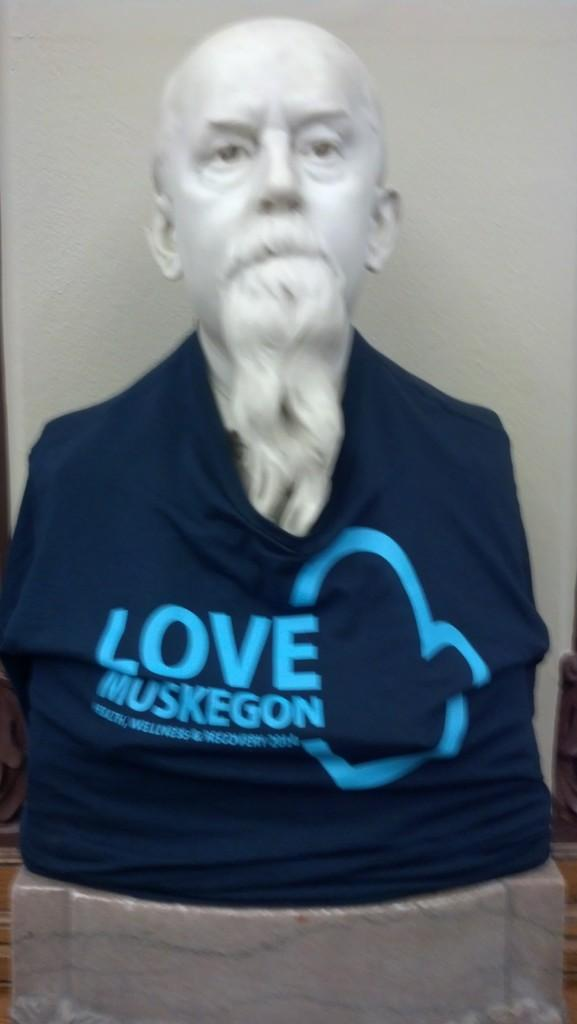What is the main subject in the middle of the image? There is a statue in the middle of the image. What is the statue wearing? The statue is wearing a t-shirt. What can be seen in the background of the image? There is a wall in the background of the image. What type of lunch is the statue eating in the image? There is no lunch present in the image, as it features a statue wearing a t-shirt in the middle of the image. 